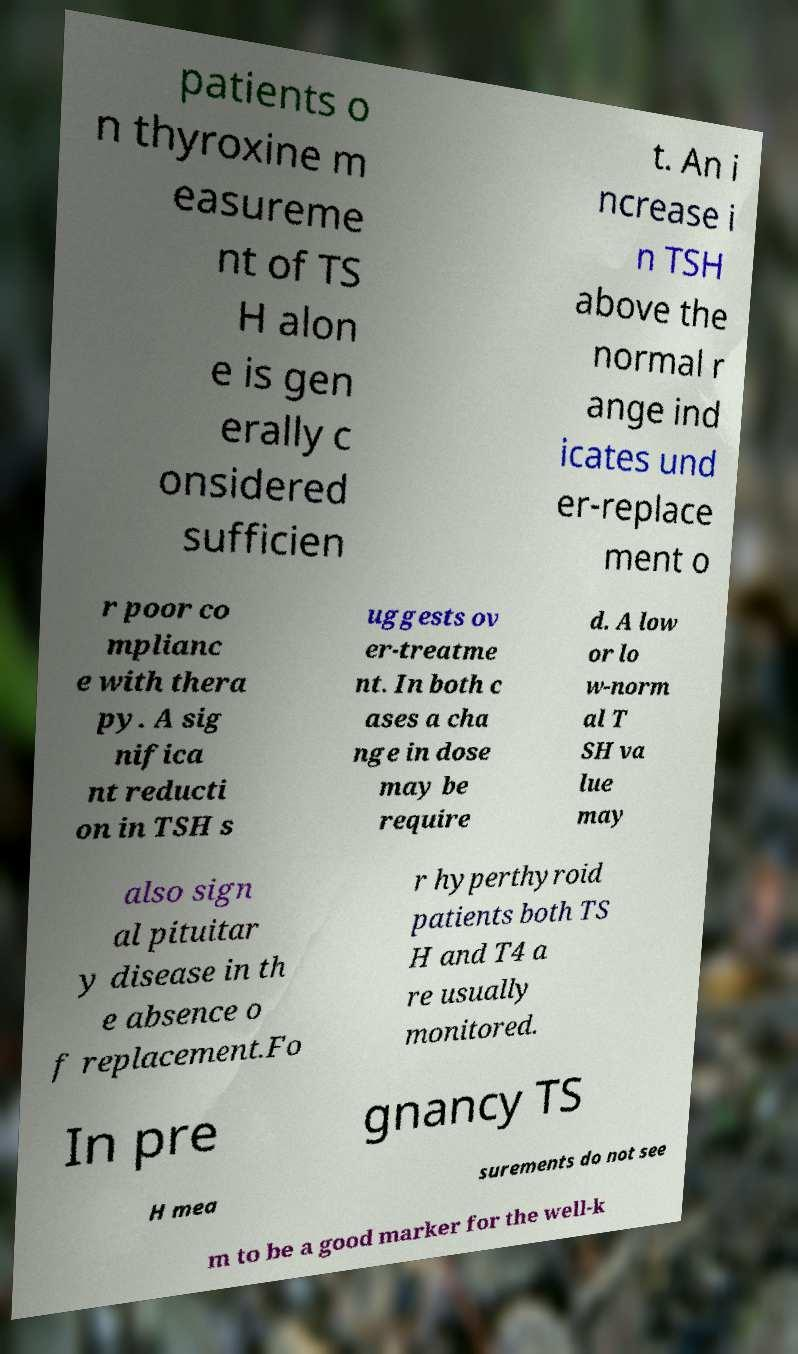There's text embedded in this image that I need extracted. Can you transcribe it verbatim? patients o n thyroxine m easureme nt of TS H alon e is gen erally c onsidered sufficien t. An i ncrease i n TSH above the normal r ange ind icates und er-replace ment o r poor co mplianc e with thera py. A sig nifica nt reducti on in TSH s uggests ov er-treatme nt. In both c ases a cha nge in dose may be require d. A low or lo w-norm al T SH va lue may also sign al pituitar y disease in th e absence o f replacement.Fo r hyperthyroid patients both TS H and T4 a re usually monitored. In pre gnancy TS H mea surements do not see m to be a good marker for the well-k 